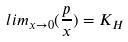Convert formula to latex. <formula><loc_0><loc_0><loc_500><loc_500>l i m _ { x \rightarrow 0 } ( \frac { p } { x } ) = K _ { H }</formula> 